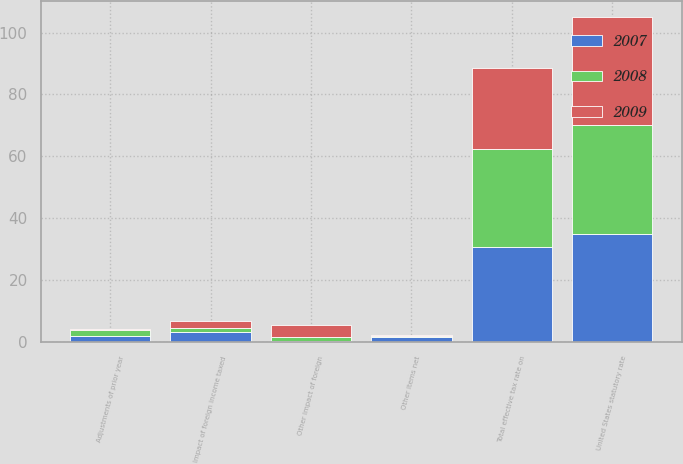Convert chart to OTSL. <chart><loc_0><loc_0><loc_500><loc_500><stacked_bar_chart><ecel><fcel>United States statutory rate<fcel>Impact of foreign income taxed<fcel>Adjustments of prior year<fcel>Other impact of foreign<fcel>Other items net<fcel>Total effective tax rate on<nl><fcel>2007<fcel>35<fcel>3.3<fcel>2.1<fcel>0.4<fcel>1.6<fcel>30.8<nl><fcel>2008<fcel>35<fcel>1.1<fcel>1.9<fcel>1.1<fcel>0.5<fcel>31.5<nl><fcel>2009<fcel>35<fcel>2.3<fcel>0.3<fcel>3.9<fcel>0.2<fcel>26.3<nl></chart> 